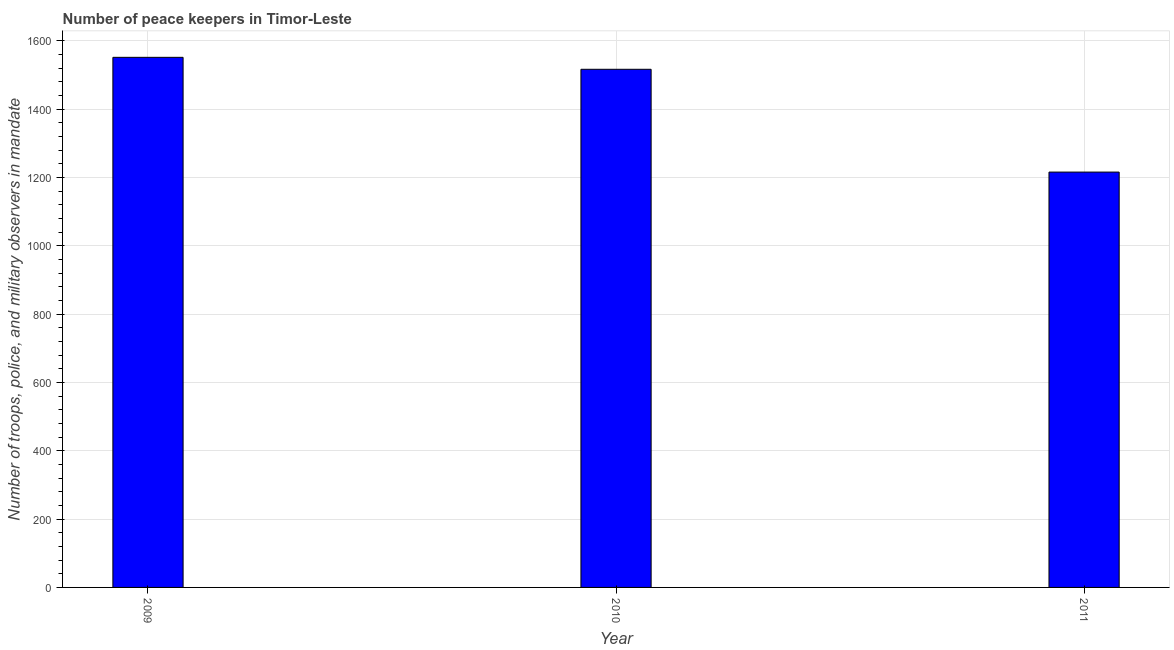Does the graph contain any zero values?
Give a very brief answer. No. What is the title of the graph?
Make the answer very short. Number of peace keepers in Timor-Leste. What is the label or title of the Y-axis?
Your answer should be compact. Number of troops, police, and military observers in mandate. What is the number of peace keepers in 2009?
Give a very brief answer. 1552. Across all years, what is the maximum number of peace keepers?
Give a very brief answer. 1552. Across all years, what is the minimum number of peace keepers?
Your answer should be compact. 1216. In which year was the number of peace keepers maximum?
Your answer should be very brief. 2009. What is the sum of the number of peace keepers?
Your response must be concise. 4285. What is the difference between the number of peace keepers in 2010 and 2011?
Your answer should be very brief. 301. What is the average number of peace keepers per year?
Give a very brief answer. 1428. What is the median number of peace keepers?
Your response must be concise. 1517. Do a majority of the years between 2011 and 2010 (inclusive) have number of peace keepers greater than 920 ?
Make the answer very short. No. What is the ratio of the number of peace keepers in 2009 to that in 2011?
Your response must be concise. 1.28. What is the difference between the highest and the second highest number of peace keepers?
Provide a short and direct response. 35. What is the difference between the highest and the lowest number of peace keepers?
Give a very brief answer. 336. How many bars are there?
Make the answer very short. 3. Are all the bars in the graph horizontal?
Your response must be concise. No. What is the difference between two consecutive major ticks on the Y-axis?
Make the answer very short. 200. What is the Number of troops, police, and military observers in mandate of 2009?
Offer a terse response. 1552. What is the Number of troops, police, and military observers in mandate in 2010?
Your response must be concise. 1517. What is the Number of troops, police, and military observers in mandate of 2011?
Make the answer very short. 1216. What is the difference between the Number of troops, police, and military observers in mandate in 2009 and 2010?
Offer a terse response. 35. What is the difference between the Number of troops, police, and military observers in mandate in 2009 and 2011?
Your response must be concise. 336. What is the difference between the Number of troops, police, and military observers in mandate in 2010 and 2011?
Your answer should be very brief. 301. What is the ratio of the Number of troops, police, and military observers in mandate in 2009 to that in 2011?
Your answer should be compact. 1.28. What is the ratio of the Number of troops, police, and military observers in mandate in 2010 to that in 2011?
Ensure brevity in your answer.  1.25. 